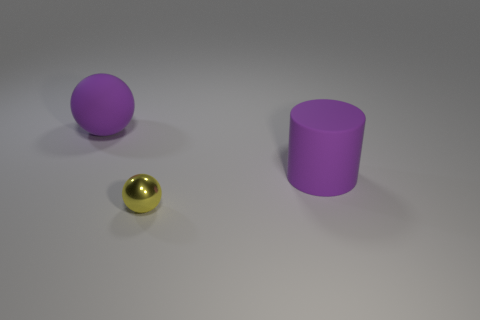Add 1 tiny shiny spheres. How many objects exist? 4 Add 3 brown metal cylinders. How many brown metal cylinders exist? 3 Subtract all yellow balls. How many balls are left? 1 Subtract 0 yellow blocks. How many objects are left? 3 Subtract all balls. How many objects are left? 1 Subtract 1 spheres. How many spheres are left? 1 Subtract all cyan cylinders. Subtract all gray balls. How many cylinders are left? 1 Subtract all red cylinders. How many yellow balls are left? 1 Subtract all large matte cylinders. Subtract all big cyan metallic spheres. How many objects are left? 2 Add 1 big rubber things. How many big rubber things are left? 3 